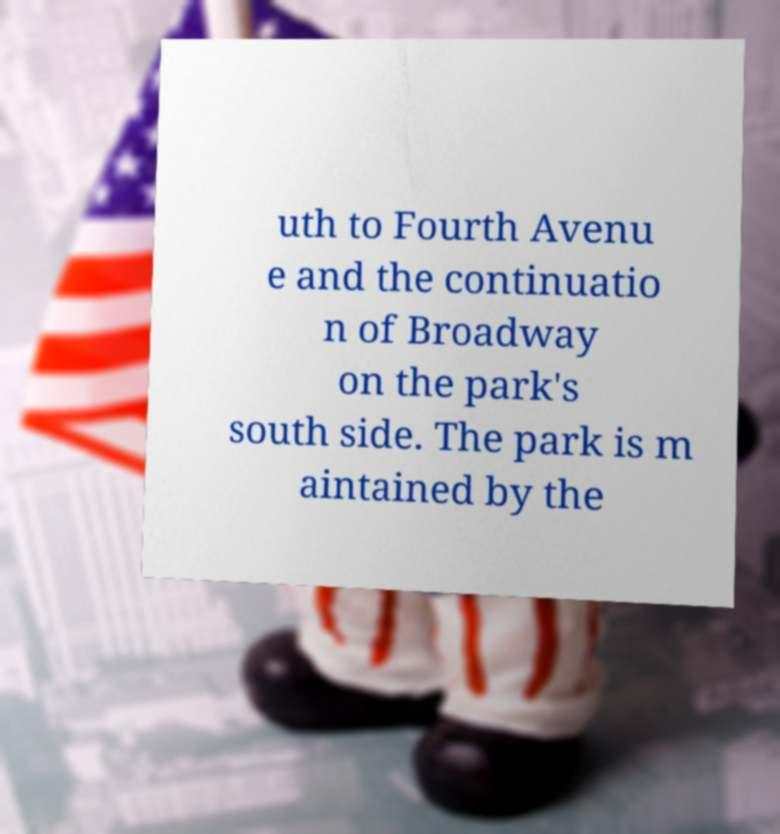Please identify and transcribe the text found in this image. uth to Fourth Avenu e and the continuatio n of Broadway on the park's south side. The park is m aintained by the 